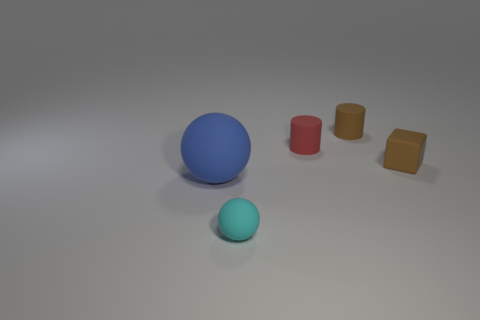Add 1 small cyan balls. How many objects exist? 6 Subtract all spheres. How many objects are left? 3 Subtract all red rubber cylinders. Subtract all small matte blocks. How many objects are left? 3 Add 2 cubes. How many cubes are left? 3 Add 5 large blue spheres. How many large blue spheres exist? 6 Subtract 1 brown blocks. How many objects are left? 4 